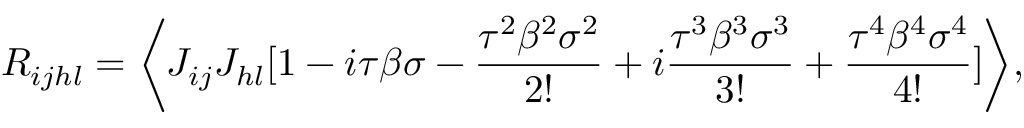Convert formula to latex. <formula><loc_0><loc_0><loc_500><loc_500>R _ { i j h l } = \left \langle J _ { i j } J _ { h l } [ 1 - i \tau \beta \sigma - \frac { \tau ^ { 2 } \beta ^ { 2 } \sigma ^ { 2 } } { 2 ! } + i \frac { \tau ^ { 3 } \beta ^ { 3 } \sigma ^ { 3 } } { 3 ! } + \frac { \tau ^ { 4 } \beta ^ { 4 } \sigma ^ { 4 } } { 4 ! } ] \right \rangle ,</formula> 